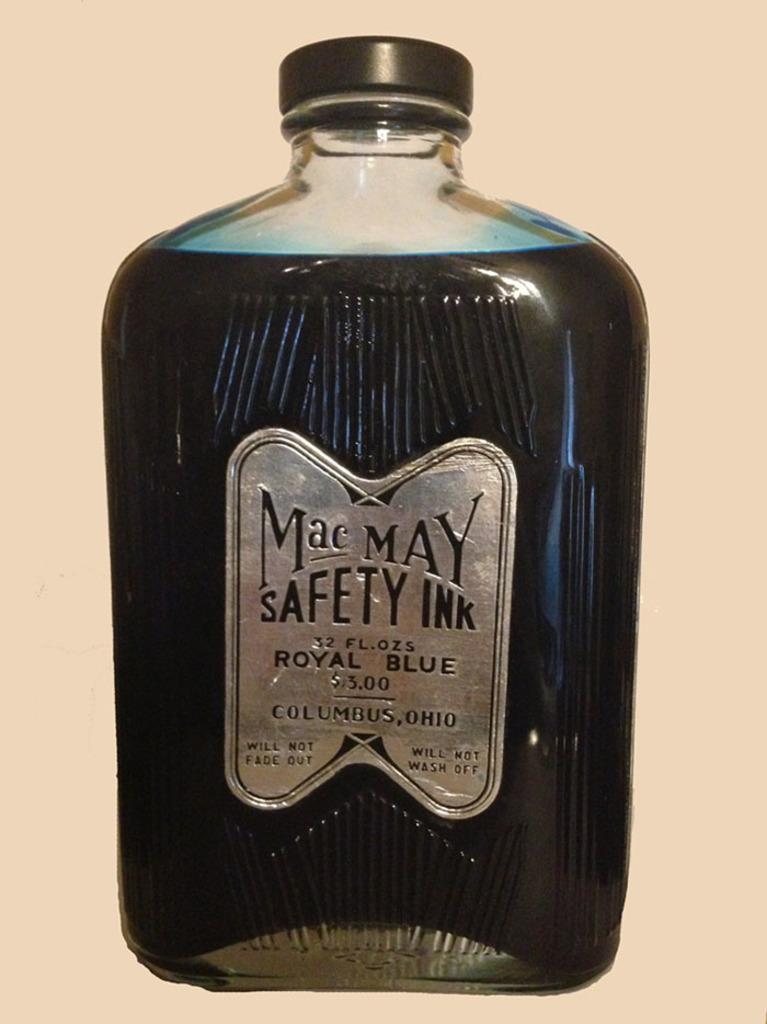What brand is this?
Provide a short and direct response. Mac may. 